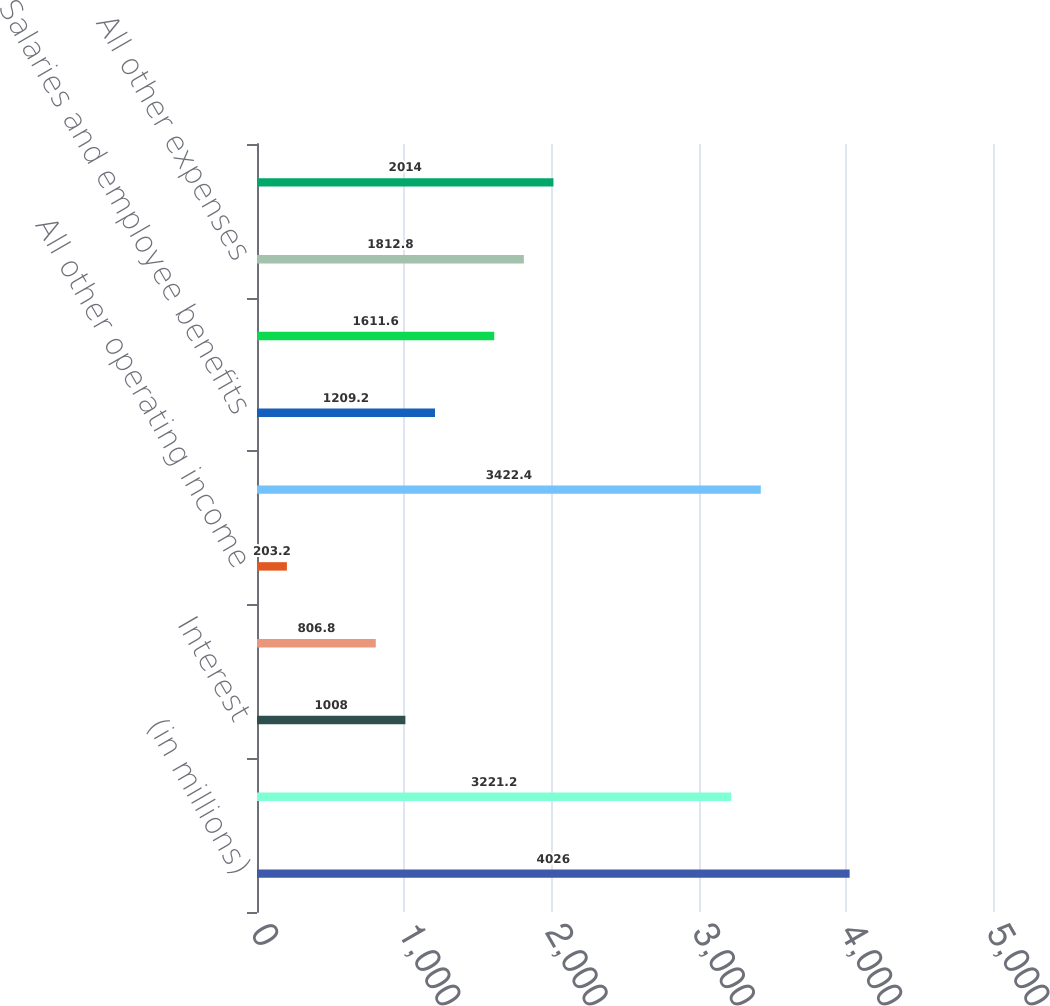<chart> <loc_0><loc_0><loc_500><loc_500><bar_chart><fcel>(in millions)<fcel>Dividends from banking<fcel>Interest<fcel>Management and service fees<fcel>All other operating income<fcel>Total operating income<fcel>Salaries and employee benefits<fcel>Interest expense<fcel>All other expenses<fcel>Total operating expense<nl><fcel>4026<fcel>3221.2<fcel>1008<fcel>806.8<fcel>203.2<fcel>3422.4<fcel>1209.2<fcel>1611.6<fcel>1812.8<fcel>2014<nl></chart> 